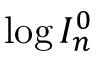Convert formula to latex. <formula><loc_0><loc_0><loc_500><loc_500>\log { I _ { n } ^ { 0 } }</formula> 